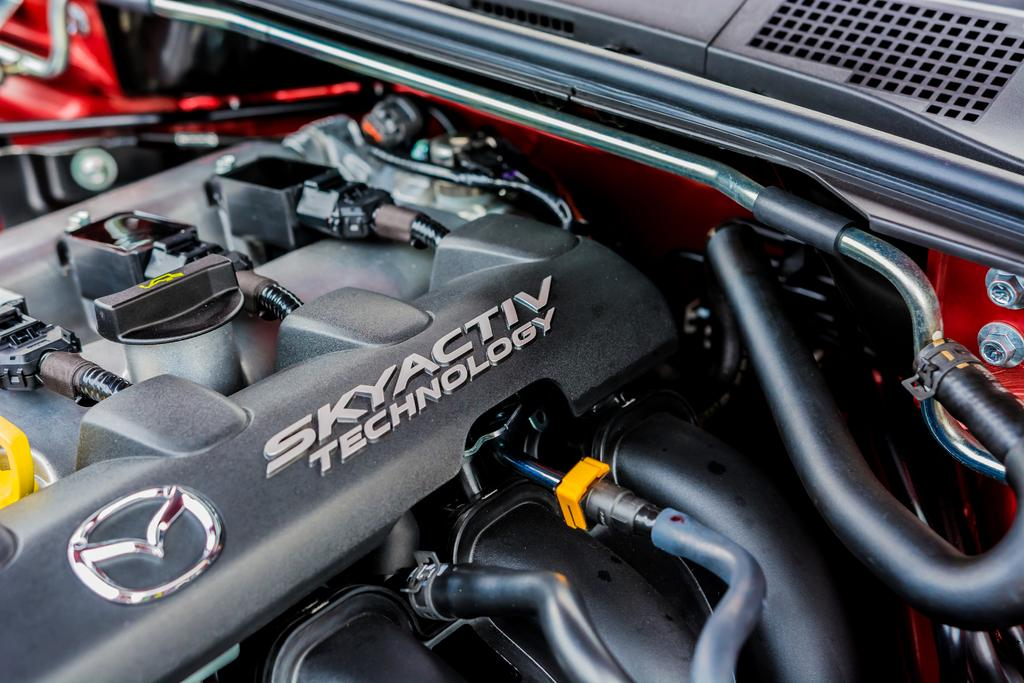What is the main subject of the image? The main subject of the image is the engine of a vehicle. What can be said about the color of the vehicle? The vehicle is in red and black color. Is there a sink visible in the image? No, there is no sink present in the image. Is there a committee meeting taking place in the image? No, there is no committee meeting depicted in the image. 